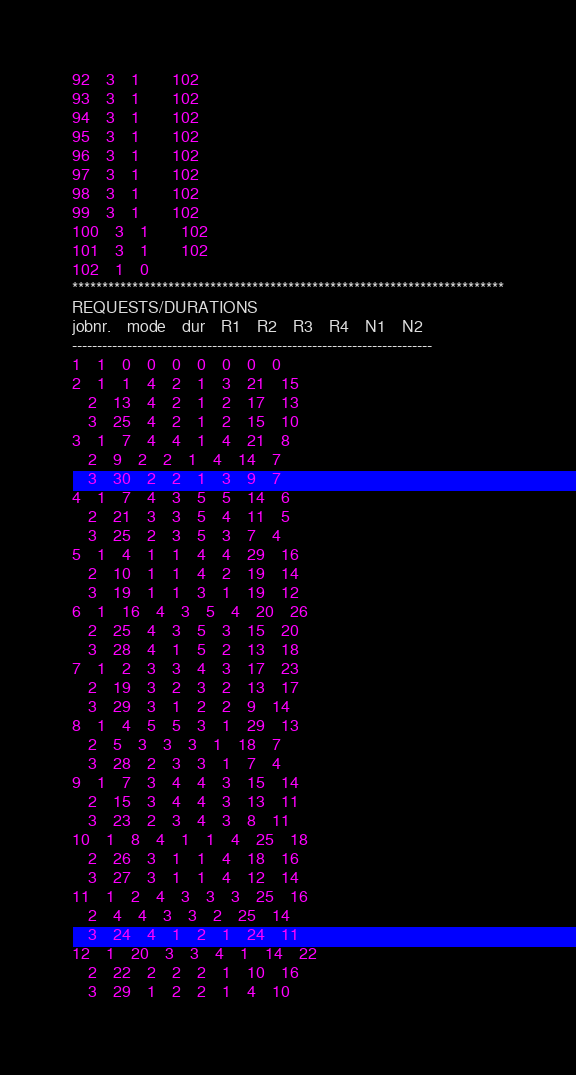<code> <loc_0><loc_0><loc_500><loc_500><_ObjectiveC_>92	3	1		102 
93	3	1		102 
94	3	1		102 
95	3	1		102 
96	3	1		102 
97	3	1		102 
98	3	1		102 
99	3	1		102 
100	3	1		102 
101	3	1		102 
102	1	0		
************************************************************************
REQUESTS/DURATIONS
jobnr.	mode	dur	R1	R2	R3	R4	N1	N2	
------------------------------------------------------------------------
1	1	0	0	0	0	0	0	0	
2	1	1	4	2	1	3	21	15	
	2	13	4	2	1	2	17	13	
	3	25	4	2	1	2	15	10	
3	1	7	4	4	1	4	21	8	
	2	9	2	2	1	4	14	7	
	3	30	2	2	1	3	9	7	
4	1	7	4	3	5	5	14	6	
	2	21	3	3	5	4	11	5	
	3	25	2	3	5	3	7	4	
5	1	4	1	1	4	4	29	16	
	2	10	1	1	4	2	19	14	
	3	19	1	1	3	1	19	12	
6	1	16	4	3	5	4	20	26	
	2	25	4	3	5	3	15	20	
	3	28	4	1	5	2	13	18	
7	1	2	3	3	4	3	17	23	
	2	19	3	2	3	2	13	17	
	3	29	3	1	2	2	9	14	
8	1	4	5	5	3	1	29	13	
	2	5	3	3	3	1	18	7	
	3	28	2	3	3	1	7	4	
9	1	7	3	4	4	3	15	14	
	2	15	3	4	4	3	13	11	
	3	23	2	3	4	3	8	11	
10	1	8	4	1	1	4	25	18	
	2	26	3	1	1	4	18	16	
	3	27	3	1	1	4	12	14	
11	1	2	4	3	3	3	25	16	
	2	4	4	3	3	2	25	14	
	3	24	4	1	2	1	24	11	
12	1	20	3	3	4	1	14	22	
	2	22	2	2	2	1	10	16	
	3	29	1	2	2	1	4	10	</code> 